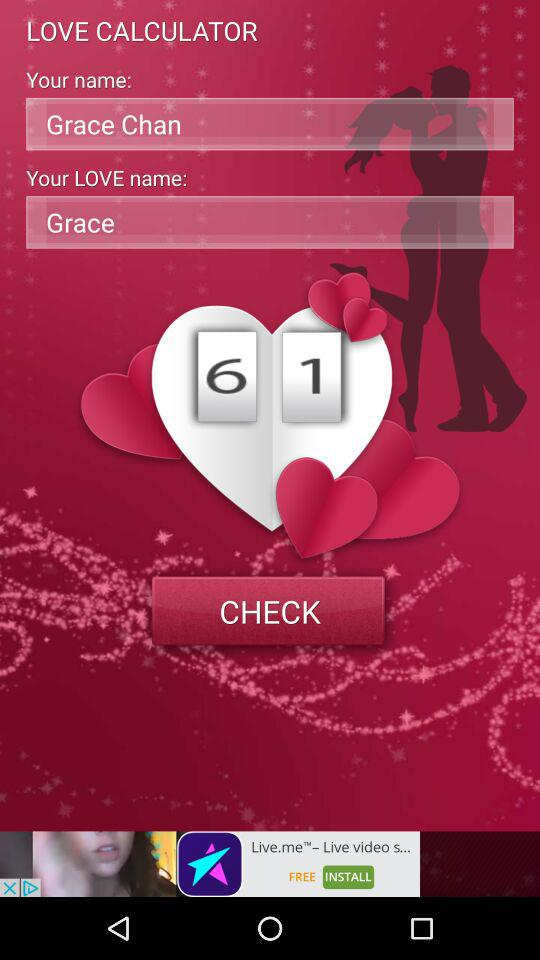What is the other person name? The other person name is Grace. 